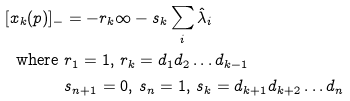<formula> <loc_0><loc_0><loc_500><loc_500>[ x _ { k } ( p ) ] _ { - } & = - r _ { k } \infty - s _ { k } \sum _ { i } \hat { \lambda } _ { i } \\ \text {where   } & r _ { 1 } = 1 , \, r _ { k } = d _ { 1 } d _ { 2 } \dots d _ { k - 1 } \\ & s _ { n + 1 } = 0 , \, s _ { n } = 1 , \, s _ { k } = d _ { k + 1 } d _ { k + 2 } \dots d _ { n } \\</formula> 